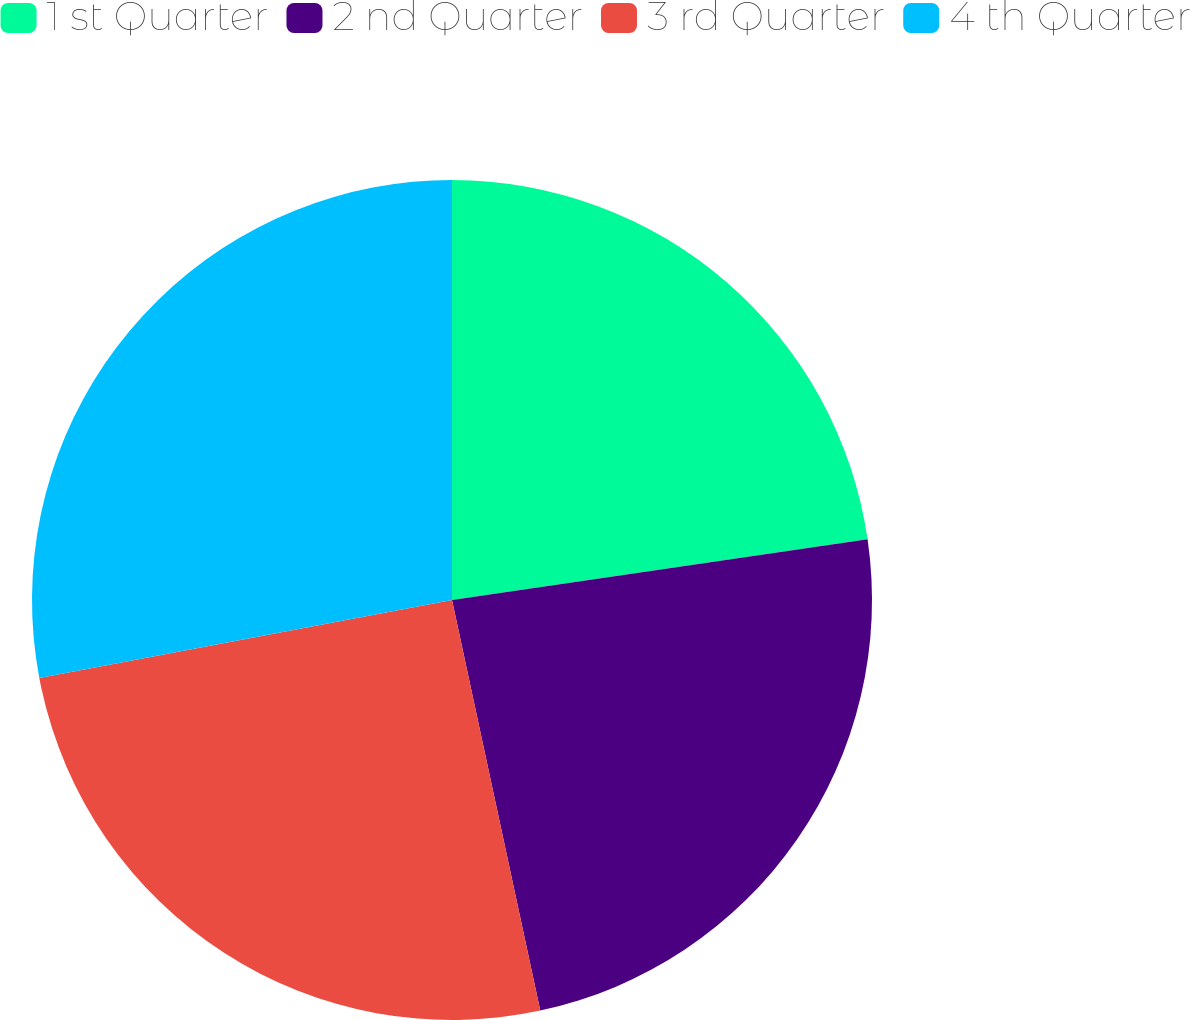<chart> <loc_0><loc_0><loc_500><loc_500><pie_chart><fcel>1 st Quarter<fcel>2 nd Quarter<fcel>3 rd Quarter<fcel>4 th Quarter<nl><fcel>22.69%<fcel>23.94%<fcel>25.4%<fcel>27.97%<nl></chart> 